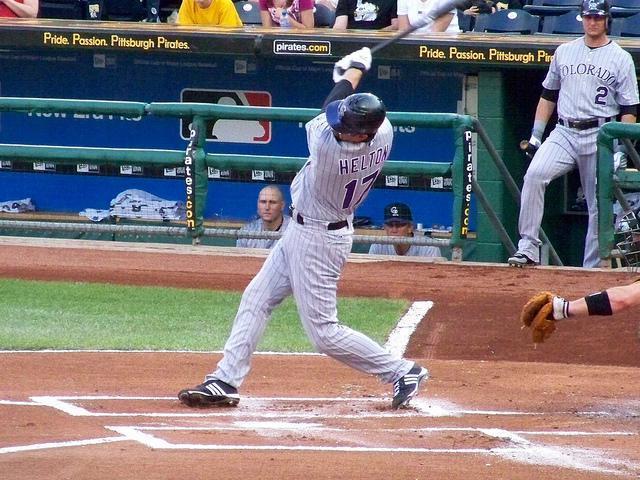How many people are there?
Give a very brief answer. 2. How many giraffes are inside the building?
Give a very brief answer. 0. 